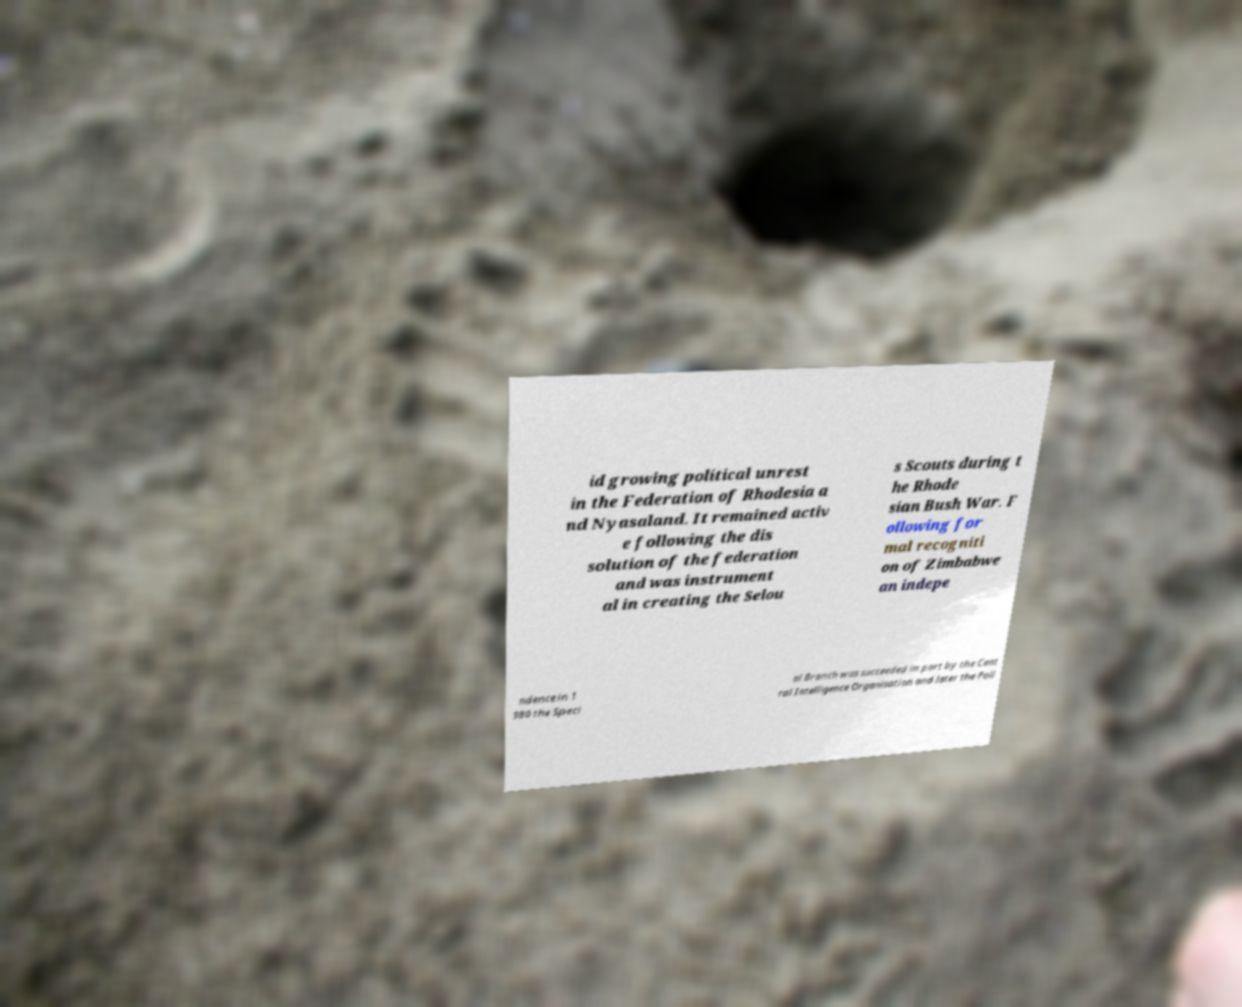Can you read and provide the text displayed in the image?This photo seems to have some interesting text. Can you extract and type it out for me? id growing political unrest in the Federation of Rhodesia a nd Nyasaland. It remained activ e following the dis solution of the federation and was instrument al in creating the Selou s Scouts during t he Rhode sian Bush War. F ollowing for mal recogniti on of Zimbabwe an indepe ndence in 1 980 the Speci al Branch was succeeded in part by the Cent ral Intelligence Organisation and later the Poli 